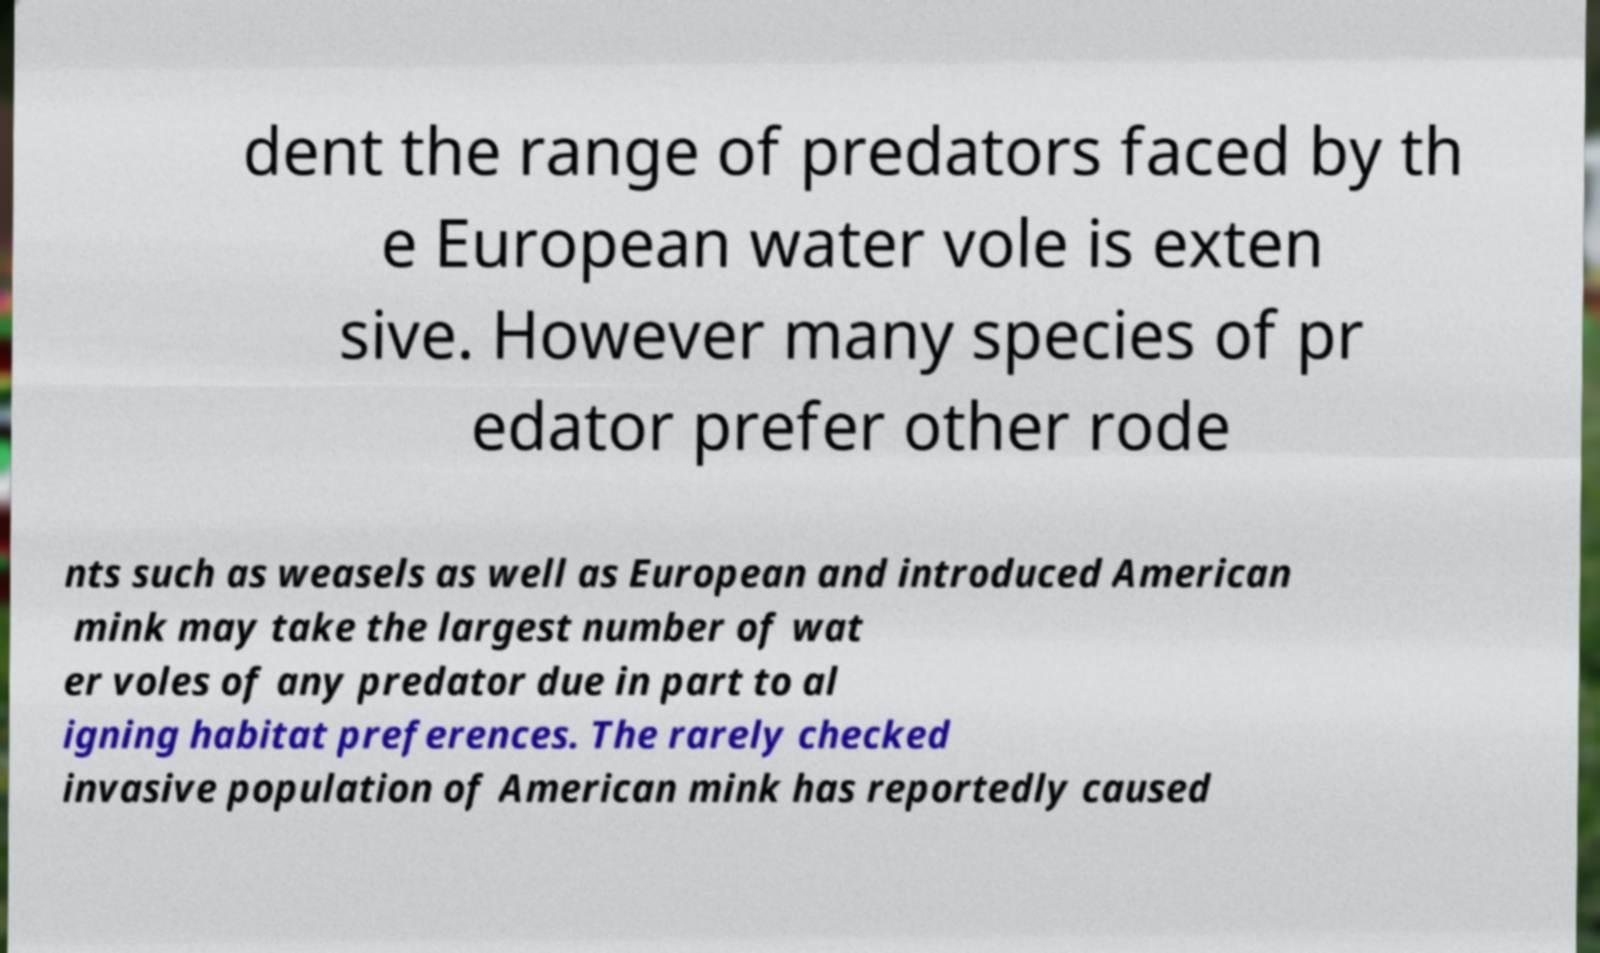I need the written content from this picture converted into text. Can you do that? dent the range of predators faced by th e European water vole is exten sive. However many species of pr edator prefer other rode nts such as weasels as well as European and introduced American mink may take the largest number of wat er voles of any predator due in part to al igning habitat preferences. The rarely checked invasive population of American mink has reportedly caused 